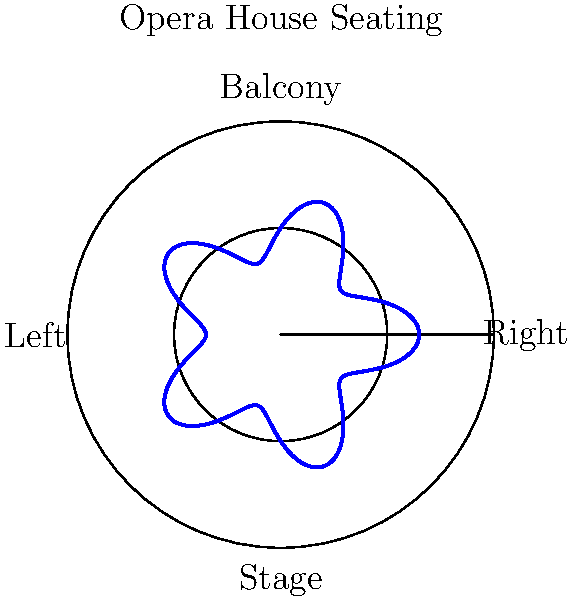In the polar coordinate representation of an opera house seating arrangement shown above, the radial distance represents the distance from the stage, and the angle represents the position around the auditorium. The blue curve shows the boundary of the seating area. What mathematical function best describes this seating arrangement, and how does it relate to the architectural style of late 19th-century opera houses? To answer this question, let's analyze the seating arrangement step-by-step:

1. Observe the shape: The blue curve has a wavy pattern that repeats five times around the circle.

2. Identify the basic function: The shape suggests a combination of a circle and a periodic function. In polar coordinates, this is typically represented as $r = a + b \cos(n\theta)$ or $r = a + b \sin(n\theta)$, where:
   - $r$ is the radial distance
   - $a$ is the average radius
   - $b$ is the amplitude of the wave
   - $n$ is the number of repetitions
   - $\theta$ is the angle

3. Determine the parameters:
   - The base circle appears to have a radius of 1 unit
   - The wave has 5 repetitions around the circle
   - The amplitude of the wave is approximately 0.3 units

4. Formulate the function: Based on these observations, the function can be written as:

   $r = 1 + 0.3 \cos(5\theta)$

5. Relate to late 19th-century opera houses:
   - This seating arrangement reflects the horseshoe shape popular in many opera houses of that era
   - The wavy pattern allows for more seats with good sightlines to the stage
   - It creates intimate box seating areas, a hallmark of 19th-century theater design
   - The design balances acoustics and visibility, crucial for operetta performances

6. Historical context:
   - This layout is reminiscent of famous opera houses like the Palais Garnier in Paris (1875) or the Metropolitan Opera House in New York (1883)
   - It represents the culmination of operetta's golden age, coinciding with the height of theater architecture innovation
Answer: $r = 1 + 0.3 \cos(5\theta)$, reflecting the horseshoe shape and box seating typical of late 19th-century opera houses. 